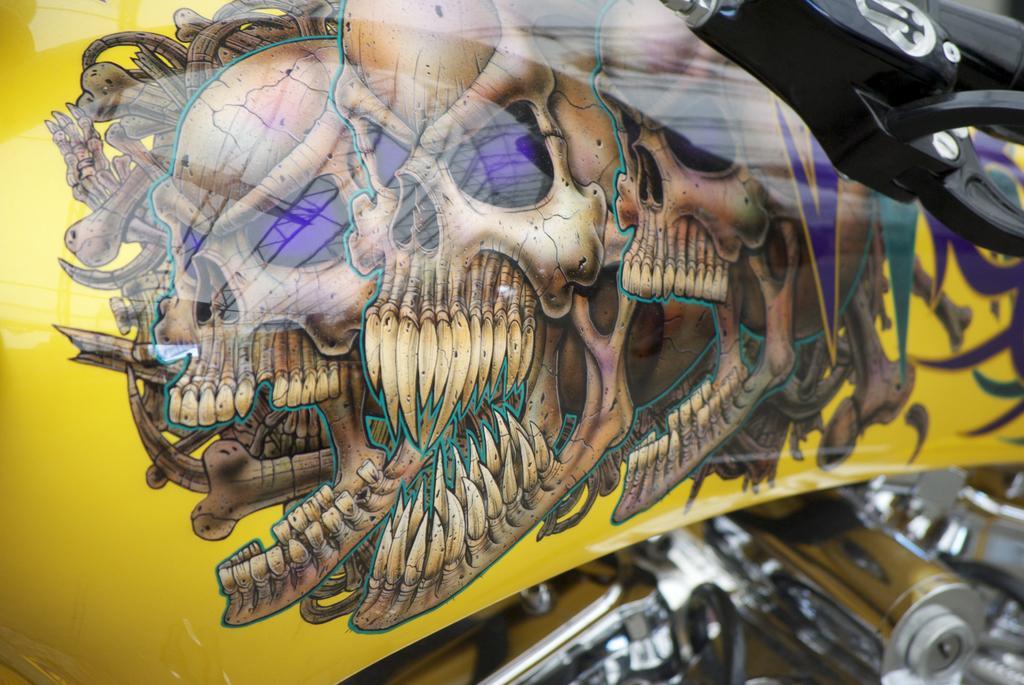Can you describe this image briefly? In the image there are skull designs on the bike. Below that there are few parts of the bike. And also there is a handle. 